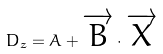Convert formula to latex. <formula><loc_0><loc_0><loc_500><loc_500>D _ { z } = A + \overrightarrow { B } \cdot \overrightarrow { X }</formula> 